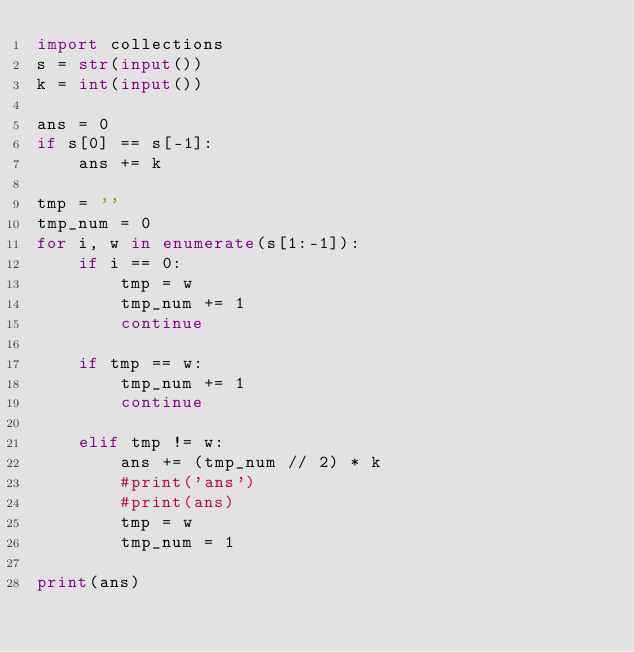<code> <loc_0><loc_0><loc_500><loc_500><_Python_>import collections
s = str(input())
k = int(input())

ans = 0
if s[0] == s[-1]:
    ans += k

tmp = ''
tmp_num = 0
for i, w in enumerate(s[1:-1]):
    if i == 0:
        tmp = w
        tmp_num += 1
        continue
    
    if tmp == w:
        tmp_num += 1
        continue
    
    elif tmp != w:
        ans += (tmp_num // 2) * k
        #print('ans')
        #print(ans)
        tmp = w
        tmp_num = 1

print(ans)

</code> 